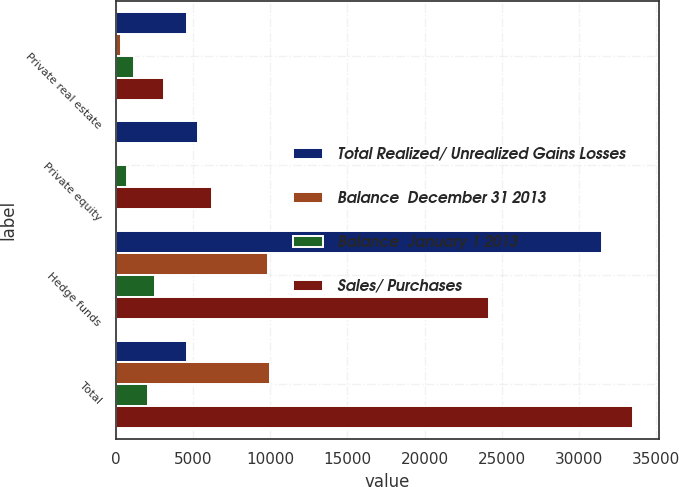Convert chart. <chart><loc_0><loc_0><loc_500><loc_500><stacked_bar_chart><ecel><fcel>Private real estate<fcel>Private equity<fcel>Hedge funds<fcel>Total<nl><fcel>Total Realized/ Unrealized Gains Losses<fcel>4603<fcel>5347<fcel>31509<fcel>4603<nl><fcel>Balance  December 31 2013<fcel>308<fcel>165<fcel>9873<fcel>10016<nl><fcel>Balance  January 1 2013<fcel>1172<fcel>687<fcel>2538<fcel>2053<nl><fcel>Sales/ Purchases<fcel>3123<fcel>6199<fcel>24174<fcel>33496<nl></chart> 